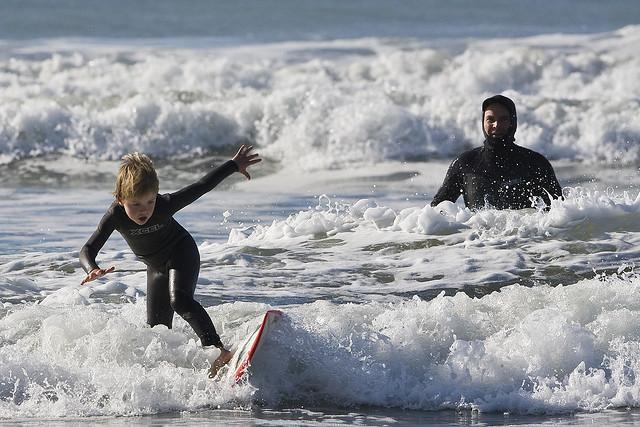Why are they wearing wetsuits? surfing 